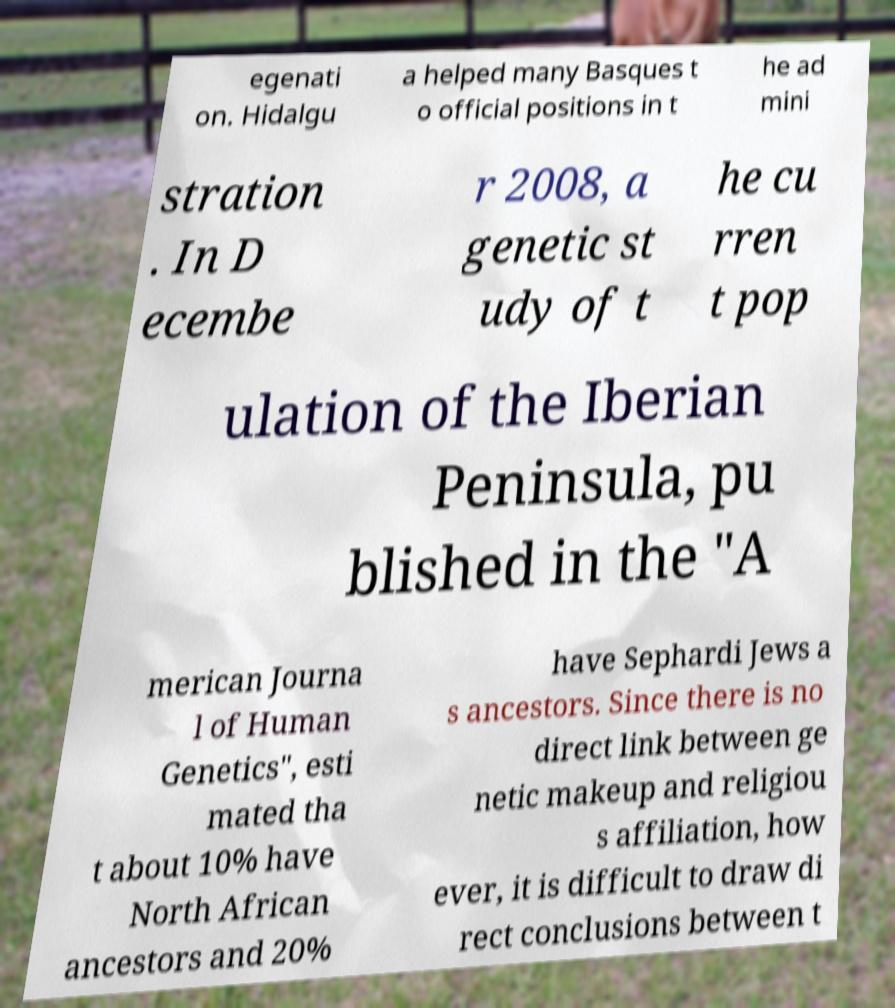Please read and relay the text visible in this image. What does it say? egenati on. Hidalgu a helped many Basques t o official positions in t he ad mini stration . In D ecembe r 2008, a genetic st udy of t he cu rren t pop ulation of the Iberian Peninsula, pu blished in the "A merican Journa l of Human Genetics", esti mated tha t about 10% have North African ancestors and 20% have Sephardi Jews a s ancestors. Since there is no direct link between ge netic makeup and religiou s affiliation, how ever, it is difficult to draw di rect conclusions between t 